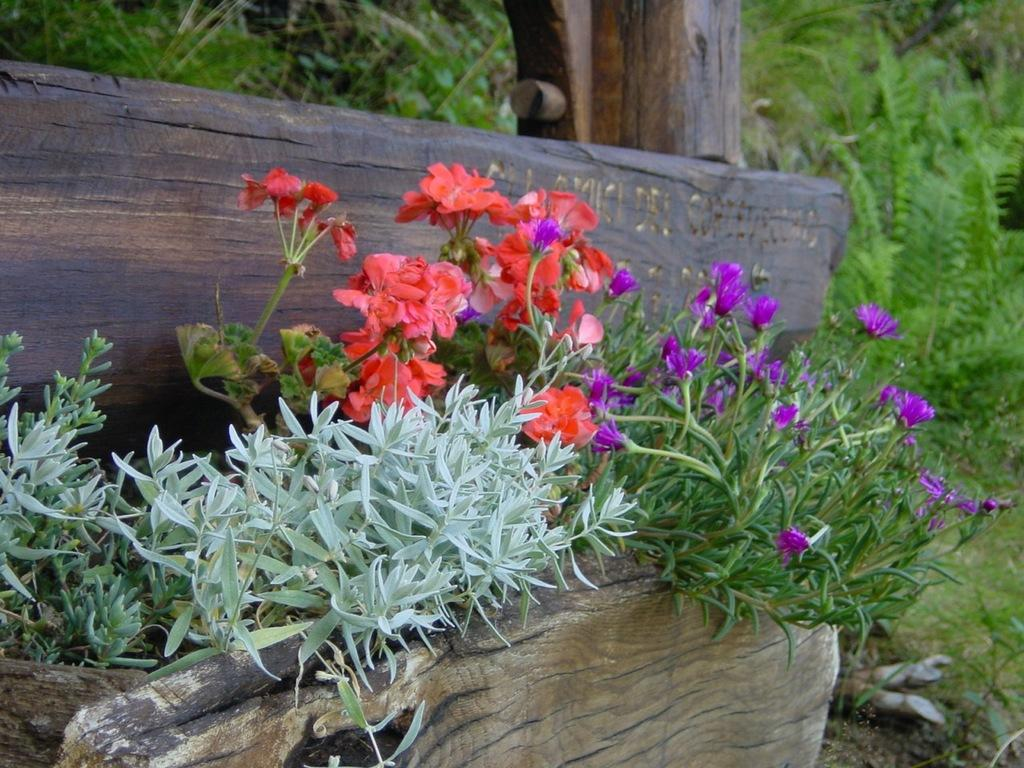What type of living organisms can be seen in the image? Plants and flowers are visible in the image. What can be seen in the background of the image? There are trees and wooden logs in the background of the image. What type of drink is being shared between the plants in the image? There is no drink present in the image, as it features plants and flowers. Can you describe the kiss between the flowers in the image? There is no kiss between the flowers in the image, as they are not living organisms capable of such actions. 